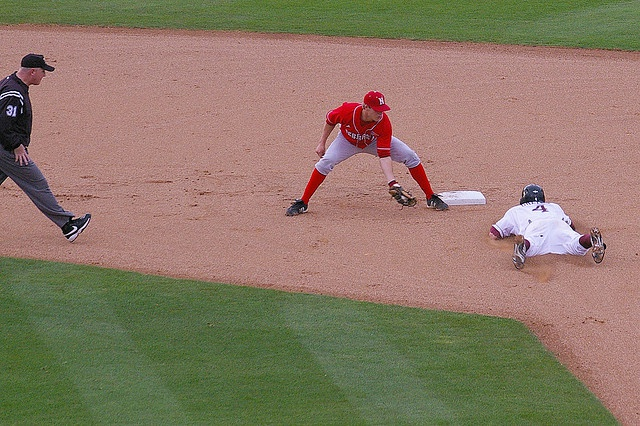Describe the objects in this image and their specific colors. I can see people in olive, maroon, darkgray, and brown tones, people in olive, black, purple, and brown tones, people in olive, lavender, gray, and darkgray tones, baseball glove in olive, black, gray, and maroon tones, and sports ball in olive, gray, darkgray, and black tones in this image. 